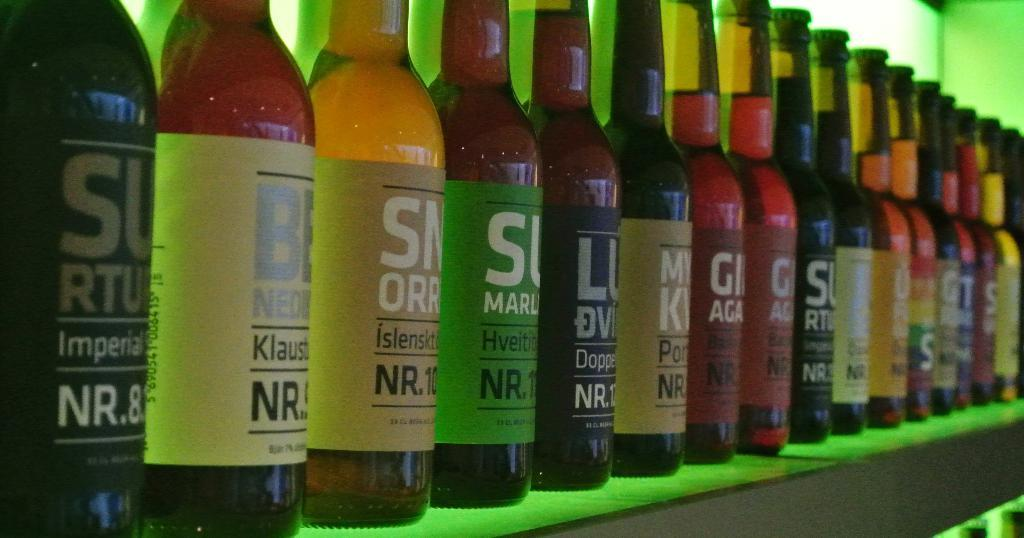<image>
Present a compact description of the photo's key features. A row of bottles of drinks, all with the letters NR on each one 